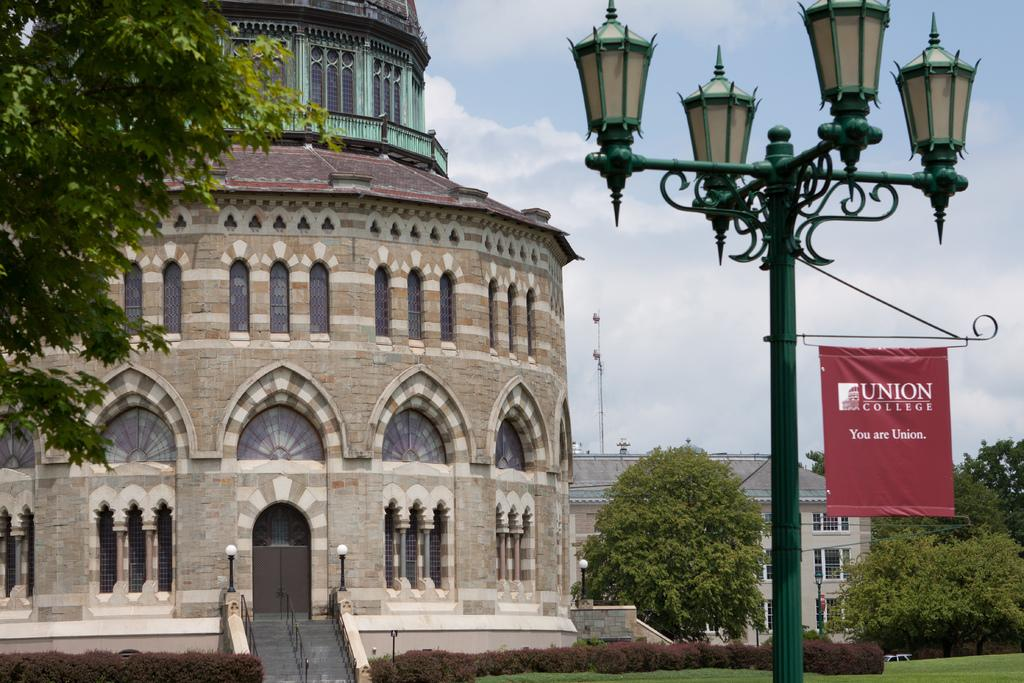What can be seen in the sky in the image? The sky with clouds is visible in the image. What type of structures are present along the street in the image? Street poles and street lights are present in the image. What is the flag associated with in the image? The flag is present in the image. What type of vegetation is visible in the image? Trees and bushes are visible in the image. What type of buildings are present in the image? Buildings are present in the image. What architectural feature is visible in the image? A staircase is in the image. What safety feature is present in the image? Railings are visible in the image. What part of the ground is visible in the image? The ground is visible in the image. Where is the father standing in the image? There is no father present in the image. What type of sun is shining in the image? There is no sun visible in the image; only clouds are present in the sky. What is the pig doing in the image? There is no pig present in the image. 